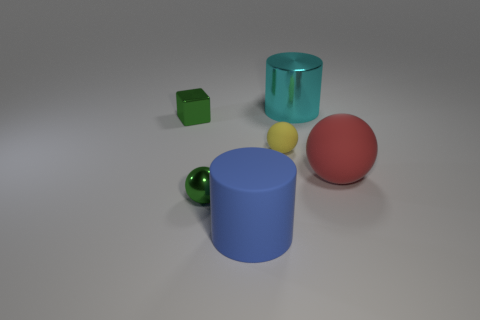Add 4 large red objects. How many objects exist? 10 Subtract all cubes. How many objects are left? 5 Add 6 cubes. How many cubes are left? 7 Add 5 tiny red cylinders. How many tiny red cylinders exist? 5 Subtract 0 gray blocks. How many objects are left? 6 Subtract all yellow matte spheres. Subtract all small green objects. How many objects are left? 3 